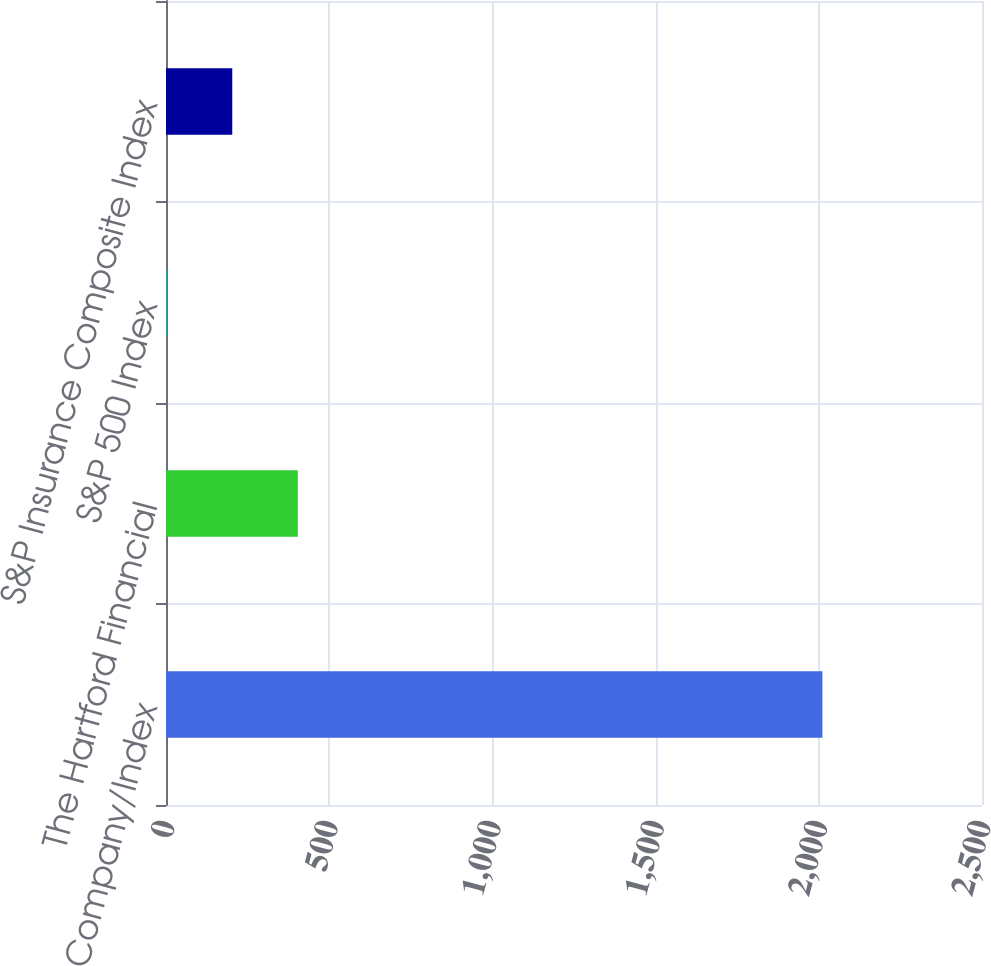<chart> <loc_0><loc_0><loc_500><loc_500><bar_chart><fcel>Company/Index<fcel>The Hartford Financial<fcel>S&P 500 Index<fcel>S&P Insurance Composite Index<nl><fcel>2011<fcel>403.89<fcel>2.11<fcel>203<nl></chart> 